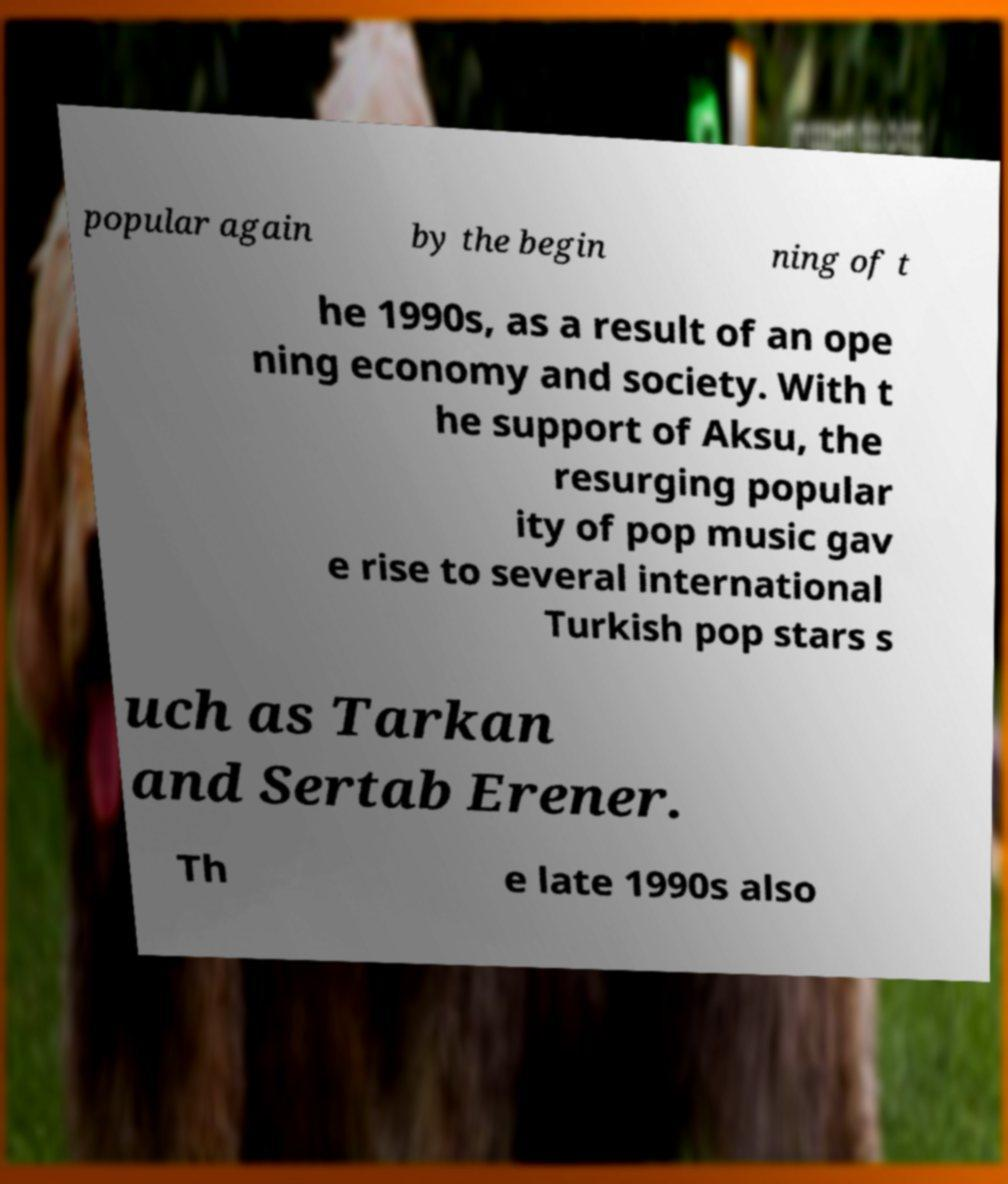Could you extract and type out the text from this image? popular again by the begin ning of t he 1990s, as a result of an ope ning economy and society. With t he support of Aksu, the resurging popular ity of pop music gav e rise to several international Turkish pop stars s uch as Tarkan and Sertab Erener. Th e late 1990s also 